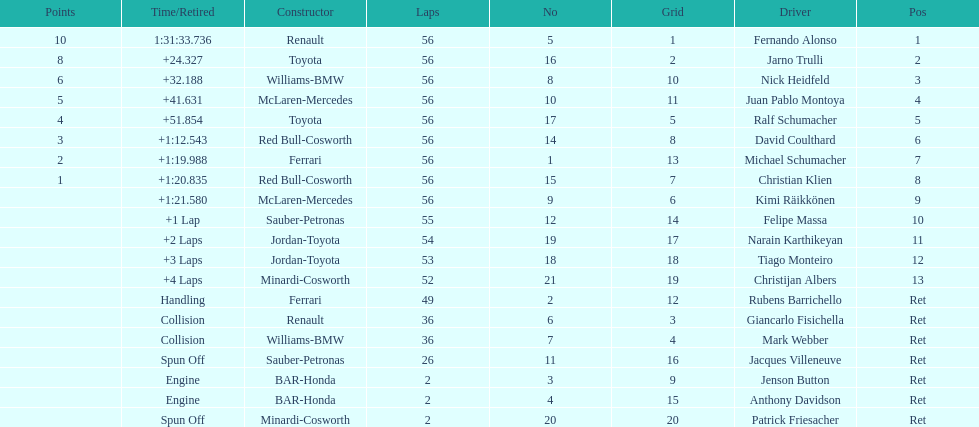Jarno trulli was not french but what nationality? Italian. 